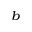<formula> <loc_0><loc_0><loc_500><loc_500>_ { b }</formula> 